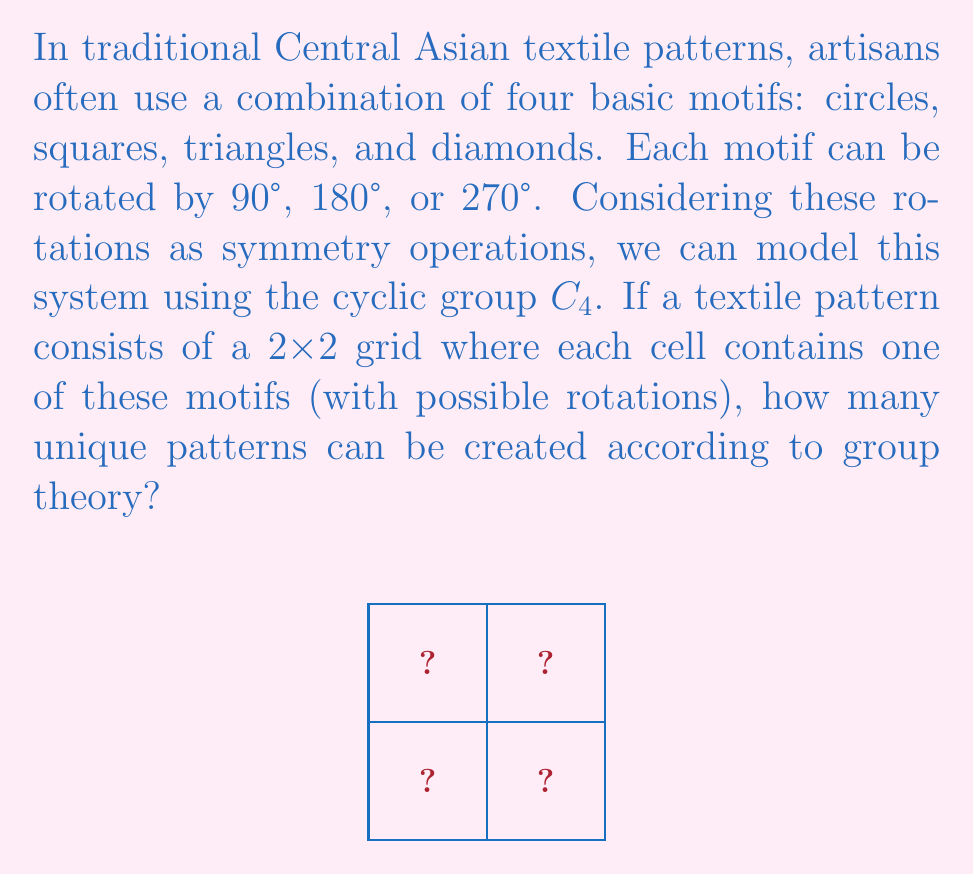Show me your answer to this math problem. Let's approach this step-by-step using group theory:

1) First, we need to understand the group structure. Each motif can be in 4 possible orientations (0°, 90°, 180°, 270°), which forms the cyclic group $C_4$.

2) We have 4 basic motifs (circle, square, triangle, diamond), each with 4 possible orientations. So for each cell, we have $4 \times 4 = 16$ possibilities.

3) Our pattern consists of a 2x2 grid, which means we're essentially creating a direct product of four $C_4$ groups: $C_4 \times C_4 \times C_4 \times C_4$.

4) According to the fundamental counting principle, if we have $n$ independent choices, each with $k_i$ options, the total number of possibilities is the product of all $k_i$.

5) In this case, we have 4 independent choices (one for each cell in the 2x2 grid), each with 16 options. Therefore, the total number of possibilities is:

   $$16 \times 16 \times 16 \times 16 = 16^4 = 2^{16} = 65,536$$

6) However, we need to consider the symmetry of the grid itself. The 2x2 grid has 4 symmetries (identity, 90° rotation, 180° rotation, 270° rotation), which form another $C_4$ group.

7) To account for these symmetries, we need to divide our total by the order of this symmetry group:

   $$\frac{65,536}{4} = 16,384$$

Therefore, according to group theory, there are 16,384 unique patterns possible in this Central Asian textile design system.
Answer: 16,384 unique patterns 